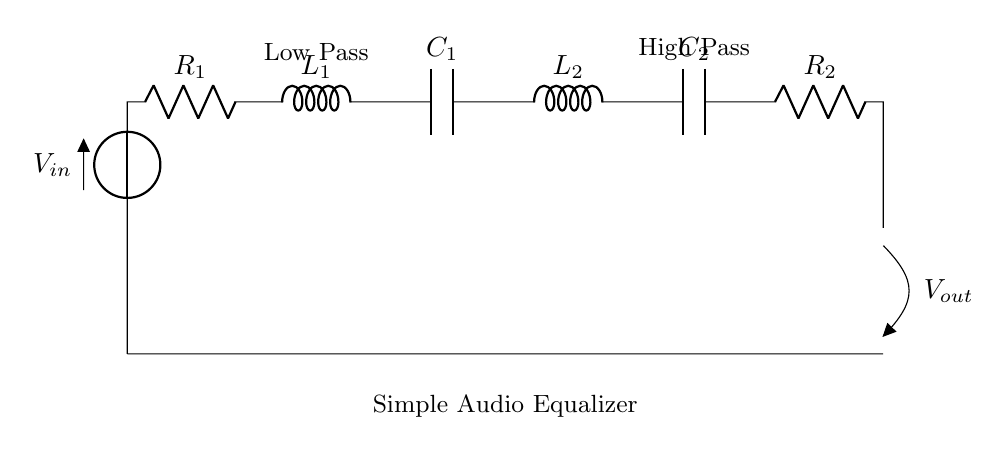What is the input voltage of the circuit? The input voltage is represented by the symbol V_in located at the top left of the circuit diagram.
Answer: V_in How many resistors are present in the circuit? The circuit diagram shows two resistors, R_1 and R_2. They are found in the left and right sections of the circuit, respectively.
Answer: Two What type of filter is implemented on the left side of the circuit? The left side of the circuit, labeled as "Low Pass," indicates that it is designed to allow low-frequency signals to pass while attenuating high-frequency signals.
Answer: Low Pass What is the order of components from left to right in the circuit? Starting from the left: input voltage, resistor (R_1), inductor (L_1), capacitor (C_1), inductor (L_2), capacitor (C_2), and resistor (R_2). This sequence follows as indicated by the connections in the circuit.
Answer: Voltage, Resistor, Inductor, Capacitor, Inductor, Capacitor, Resistor How do the inductors and capacitors interact in this circuit? Inductors and capacitors together form LC circuits, where they can create resonance at particular frequencies. In this case, L_1 and C_1 help in low pass filtering, while L_2 and C_2 assist in high pass filtering, working against each other to equalize audio signals.
Answer: Form LC circuits 